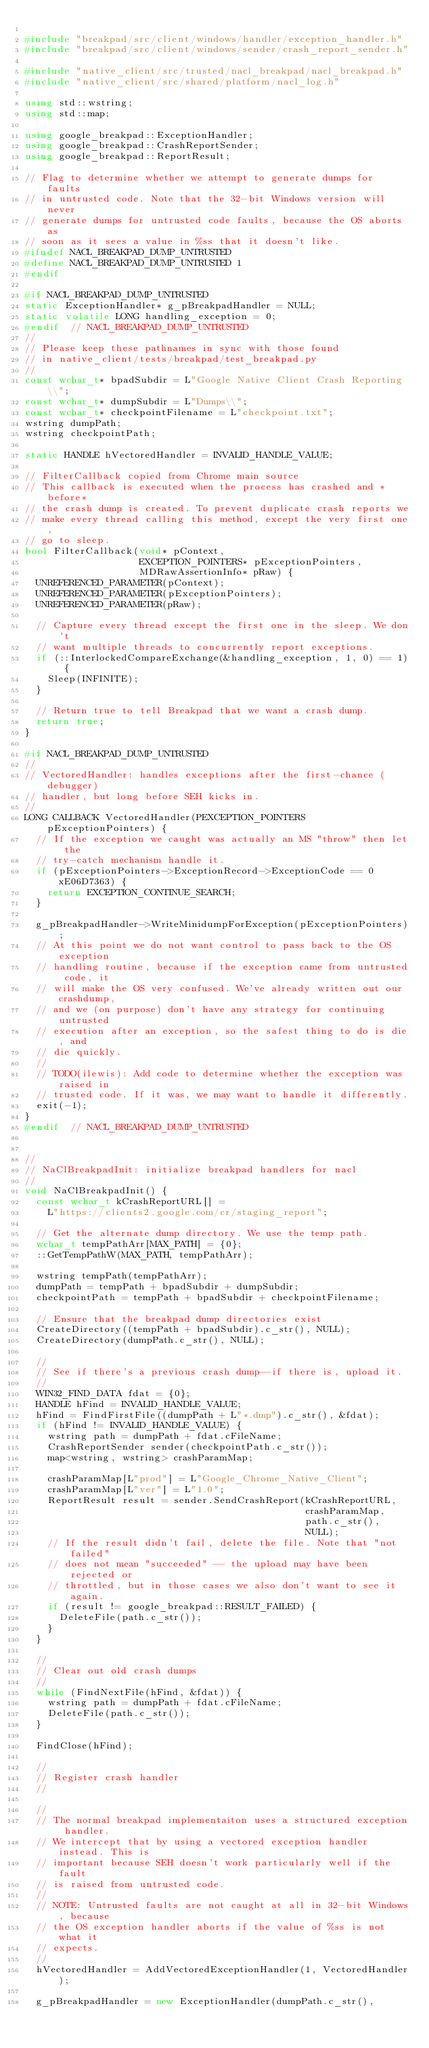<code> <loc_0><loc_0><loc_500><loc_500><_C++_>
#include "breakpad/src/client/windows/handler/exception_handler.h"
#include "breakpad/src/client/windows/sender/crash_report_sender.h"

#include "native_client/src/trusted/nacl_breakpad/nacl_breakpad.h"
#include "native_client/src/shared/platform/nacl_log.h"

using std::wstring;
using std::map;

using google_breakpad::ExceptionHandler;
using google_breakpad::CrashReportSender;
using google_breakpad::ReportResult;

// Flag to determine whether we attempt to generate dumps for faults
// in untrusted code. Note that the 32-bit Windows version will never
// generate dumps for untrusted code faults, because the OS aborts as
// soon as it sees a value in %ss that it doesn't like.
#ifndef NACL_BREAKPAD_DUMP_UNTRUSTED
#define NACL_BREAKPAD_DUMP_UNTRUSTED 1
#endif

#if NACL_BREAKPAD_DUMP_UNTRUSTED
static ExceptionHandler* g_pBreakpadHandler = NULL;
static volatile LONG handling_exception = 0;
#endif  // NACL_BREAKPAD_DUMP_UNTRUSTED
//
// Please keep these pathnames in sync with those found
// in native_client/tests/breakpad/test_breakpad.py
//
const wchar_t* bpadSubdir = L"Google Native Client Crash Reporting\\";
const wchar_t* dumpSubdir = L"Dumps\\";
const wchar_t* checkpointFilename = L"checkpoint.txt";
wstring dumpPath;
wstring checkpointPath;

static HANDLE hVectoredHandler = INVALID_HANDLE_VALUE;

// FilterCallback copied from Chrome main source
// This callback is executed when the process has crashed and *before*
// the crash dump is created. To prevent duplicate crash reports we
// make every thread calling this method, except the very first one,
// go to sleep.
bool FilterCallback(void* pContext,
                    EXCEPTION_POINTERS* pExceptionPointers,
                    MDRawAssertionInfo* pRaw) {
  UNREFERENCED_PARAMETER(pContext);
  UNREFERENCED_PARAMETER(pExceptionPointers);
  UNREFERENCED_PARAMETER(pRaw);

  // Capture every thread except the first one in the sleep. We don't
  // want multiple threads to concurrently report exceptions.
  if (::InterlockedCompareExchange(&handling_exception, 1, 0) == 1) {
    Sleep(INFINITE);
  }

  // Return true to tell Breakpad that we want a crash dump.
  return true;
}

#if NACL_BREAKPAD_DUMP_UNTRUSTED
//
// VectoredHandler: handles exceptions after the first-chance (debugger)
// handler, but long before SEH kicks in.
//
LONG CALLBACK VectoredHandler(PEXCEPTION_POINTERS pExceptionPointers) {
  // If the exception we caught was actually an MS "throw" then let the
  // try-catch mechanism handle it.
  if (pExceptionPointers->ExceptionRecord->ExceptionCode == 0xE06D7363) {
    return EXCEPTION_CONTINUE_SEARCH;
  }

  g_pBreakpadHandler->WriteMinidumpForException(pExceptionPointers);
  // At this point we do not want control to pass back to the OS exception
  // handling routine, because if the exception came from untrusted code, it
  // will make the OS very confused. We've already written out our crashdump,
  // and we (on purpose) don't have any strategy for continuing untrusted
  // execution after an exception, so the safest thing to do is die, and
  // die quickly.
  //
  // TODO(ilewis): Add code to determine whether the exception was raised in
  // trusted code. If it was, we may want to handle it differently.
  exit(-1);
}
#endif  // NACL_BREAKPAD_DUMP_UNTRUSTED


//
// NaClBreakpadInit: initialize breakpad handlers for nacl
//
void NaClBreakpadInit() {
  const wchar_t kCrashReportURL[] =
    L"https://clients2.google.com/cr/staging_report";

  // Get the alternate dump directory. We use the temp path.
  wchar_t tempPathArr[MAX_PATH] = {0};
  ::GetTempPathW(MAX_PATH, tempPathArr);

  wstring tempPath(tempPathArr);
  dumpPath = tempPath + bpadSubdir + dumpSubdir;
  checkpointPath = tempPath + bpadSubdir + checkpointFilename;

  // Ensure that the breakpad dump directories exist
  CreateDirectory((tempPath + bpadSubdir).c_str(), NULL);
  CreateDirectory(dumpPath.c_str(), NULL);

  //
  // See if there's a previous crash dump--if there is, upload it.
  //
  WIN32_FIND_DATA fdat = {0};
  HANDLE hFind = INVALID_HANDLE_VALUE;
  hFind = FindFirstFile((dumpPath + L"*.dmp").c_str(), &fdat);
  if (hFind != INVALID_HANDLE_VALUE) {
    wstring path = dumpPath + fdat.cFileName;
    CrashReportSender sender(checkpointPath.c_str());
    map<wstring, wstring> crashParamMap;

    crashParamMap[L"prod"] = L"Google_Chrome_Native_Client";
    crashParamMap[L"ver"] = L"1.0";
    ReportResult result = sender.SendCrashReport(kCrashReportURL,
                                                 crashParamMap,
                                                 path.c_str(),
                                                 NULL);
    // If the result didn't fail, delete the file. Note that "not failed"
    // does not mean "succeeded" -- the upload may have been rejected or
    // throttled, but in those cases we also don't want to see it again.
    if (result != google_breakpad::RESULT_FAILED) {
      DeleteFile(path.c_str());
    }
  }

  //
  // Clear out old crash dumps
  //
  while (FindNextFile(hFind, &fdat)) {
    wstring path = dumpPath + fdat.cFileName;
    DeleteFile(path.c_str());
  }

  FindClose(hFind);

  //
  // Register crash handler
  //

  //
  // The normal breakpad implementaiton uses a structured exception handler.
  // We intercept that by using a vectored exception handler instead. This is
  // important because SEH doesn't work particularly well if the fault
  // is raised from untrusted code.
  //
  // NOTE: Untrusted faults are not caught at all in 32-bit Windows, because
  // the OS exception handler aborts if the value of %ss is not what it
  // expects.
  //
  hVectoredHandler = AddVectoredExceptionHandler(1, VectoredHandler);

  g_pBreakpadHandler = new ExceptionHandler(dumpPath.c_str(),</code> 